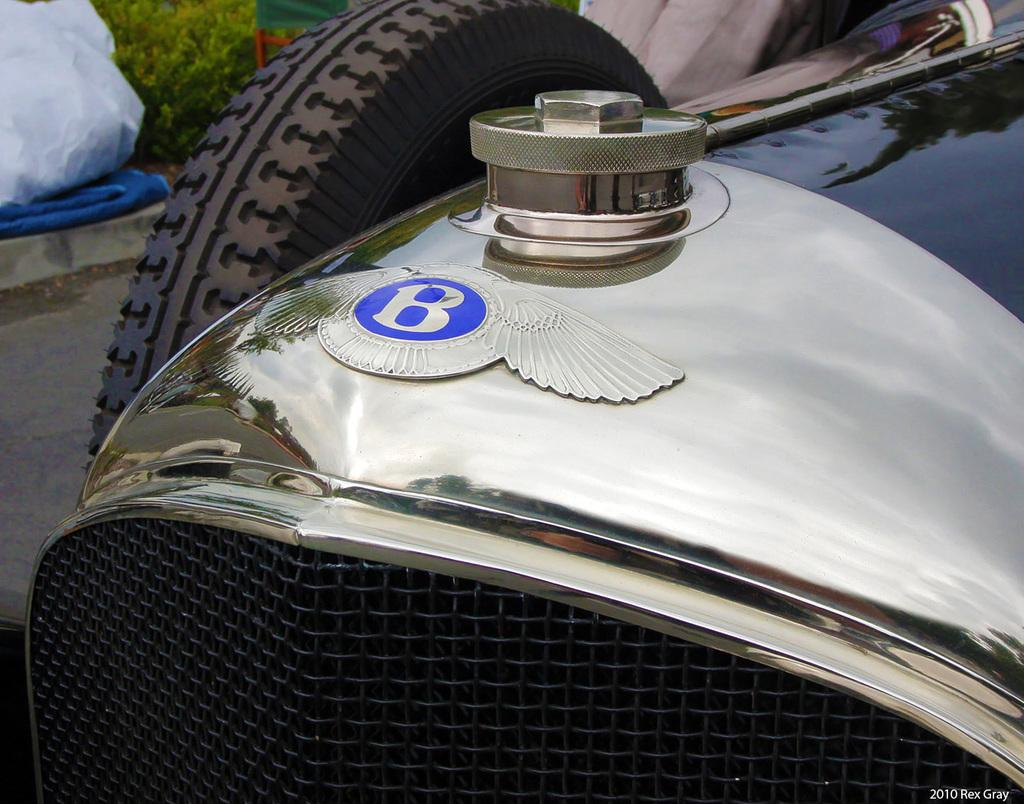What is on the vehicle in the image? There is a logo on the vehicle. What is located behind the vehicle? There is a tyre behind the vehicle. What type of natural elements can be seen in the image? Plants are visible in the image. What type of object is present in the image, made of plastic and commonly used for carrying items? A polyethylene bag is present in the image. What other objects can be seen in the image besides the vehicle, tyre, plants, and polyethylene bag? There are other objects in the image. Where is the library located in the image? There is no library present in the image. What type of container is used for holding water in the image? There is no container for holding water present in the image. 